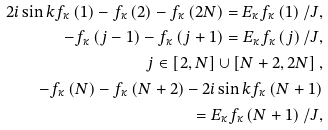<formula> <loc_0><loc_0><loc_500><loc_500>2 i \sin k f _ { \kappa } \left ( 1 \right ) - f _ { \kappa } \left ( 2 \right ) - f _ { \kappa } \left ( 2 N \right ) = E _ { \kappa } f _ { \kappa } \left ( 1 \right ) / J , & \\ - f _ { \kappa } \left ( j - 1 \right ) - f _ { \kappa } \left ( j + 1 \right ) = E _ { \kappa } f _ { \kappa } \left ( j \right ) / J , & \\ j \in \left [ 2 , N \right ] \cup \left [ N + 2 , 2 N \right ] , & \\ - f _ { \kappa } \left ( N \right ) - f _ { \kappa } \left ( N + 2 \right ) - 2 i \sin k f _ { \kappa } \left ( N + 1 \right ) & \\ = E _ { \kappa } f _ { \kappa } \left ( N + 1 \right ) / J , &</formula> 